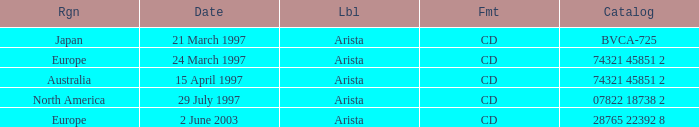What's the Date for the Region of Europe and has the Catalog of 28765 22392 8? 2 June 2003. 